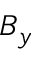Convert formula to latex. <formula><loc_0><loc_0><loc_500><loc_500>B _ { y }</formula> 